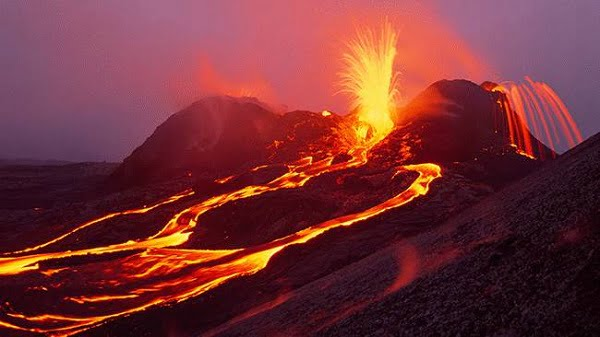Can you explain how volcanoes like this one are monitored to predict eruptions? Volcanoes such as the one in the image are typically monitored using a combination of seismic activity recorders, ground deformation measurement devices, and gas emission sensors. Seismographs help detect the earthquakes that often precede eruptions. Ground deformation instruments like tiltmeters and GPS measure the slightest bulges in the volcano's surface, indicating magma movement. Gas analyzers sample the sulfur dioxide and other gases released, as changes in quantity can signify rising magma. Together, these tools help scientists predict potential eruptions and issue timely warnings to minimize impacts on human safety. 